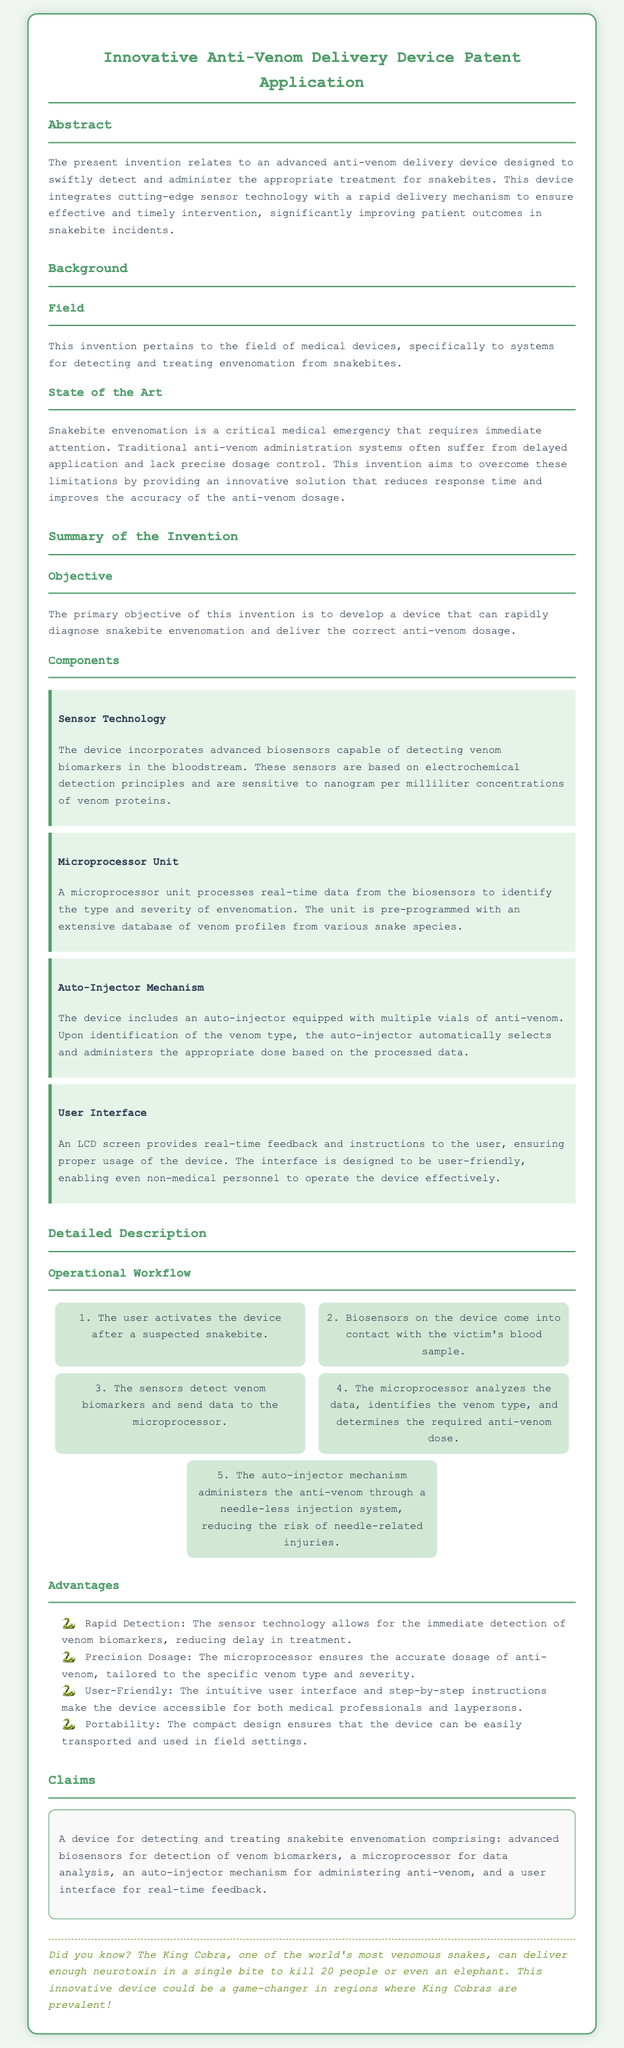What is the primary objective of the invention? The primary objective is to develop a device that can rapidly diagnose snakebite envenomation and deliver the correct anti-venom dosage.
Answer: Develop a device that can rapidly diagnose snakebite envenomation and deliver the correct anti-venom dosage What technology do the sensors use? The sensors are based on electrochemical detection principles and are sensitive to nanogram per milliliter concentrations of venom proteins.
Answer: Electrochemical detection principles What is the role of the microprocessor unit? The microprocessor processes real-time data from the biosensors to identify the type and severity of envenomation.
Answer: Identify the type and severity of envenomation List an advantage of the device. One advantage is rapid detection; the sensor technology allows for immediate detection of venom biomarkers.
Answer: Rapid detection How many steps are in the operational workflow? There are five steps in the operational workflow outlined in the document.
Answer: Five steps What does the user interface provide? The user interface provides real-time feedback and instructions to the user.
Answer: Real-time feedback and instructions Which component administers the anti-venom? The component that administers the anti-venom is the auto-injector mechanism.
Answer: Auto-injector mechanism What type of emergency does this device address? This device addresses snakebite envenomation, which is a critical medical emergency.
Answer: Snakebite envenomation What is the unique feature of the injection system? The unique feature is a needle-less injection system, reducing the risk of needle-related injuries.
Answer: Needle-less injection system 